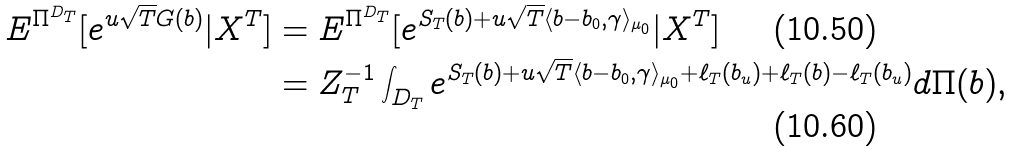<formula> <loc_0><loc_0><loc_500><loc_500>E ^ { \Pi ^ { D _ { T } } } [ e ^ { u \sqrt { T } G ( b ) } | X ^ { T } ] & = E ^ { \Pi ^ { D _ { T } } } [ e ^ { S _ { T } ( b ) + u \sqrt { T } \langle b - b _ { 0 } , \gamma \rangle _ { \mu _ { 0 } } } | X ^ { T } ] \\ & = Z _ { T } ^ { - 1 } \int _ { D _ { T } } e ^ { S _ { T } ( b ) + u \sqrt { T } \langle b - b _ { 0 } , \gamma \rangle _ { \mu _ { 0 } } + \ell _ { T } ( b _ { u } ) + \ell _ { T } ( b ) - \ell _ { T } ( b _ { u } ) } d \Pi ( b ) ,</formula> 